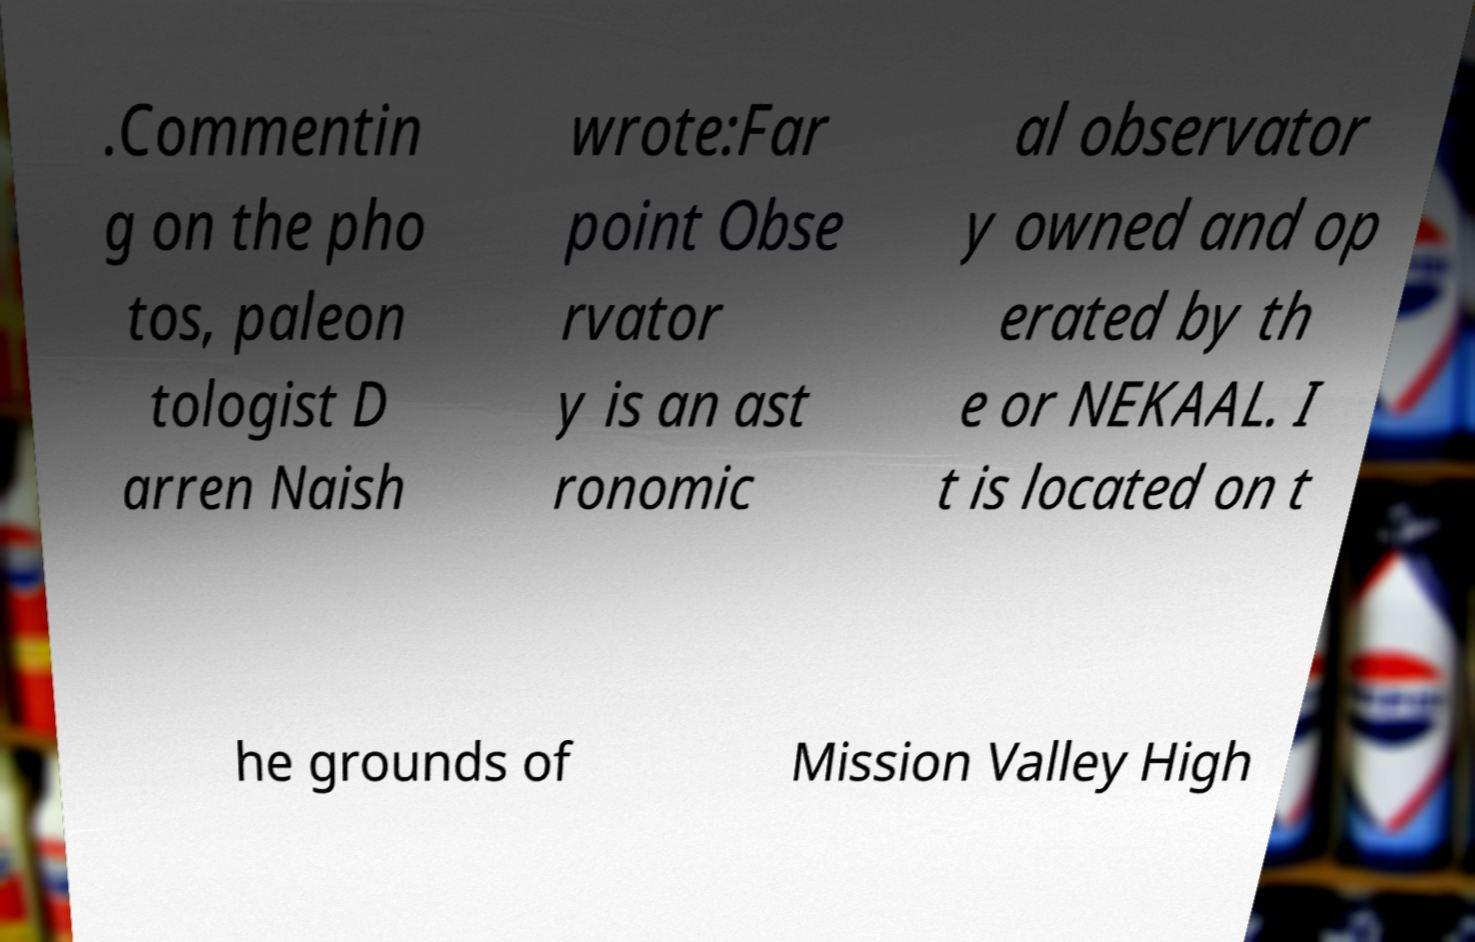Can you accurately transcribe the text from the provided image for me? .Commentin g on the pho tos, paleon tologist D arren Naish wrote:Far point Obse rvator y is an ast ronomic al observator y owned and op erated by th e or NEKAAL. I t is located on t he grounds of Mission Valley High 